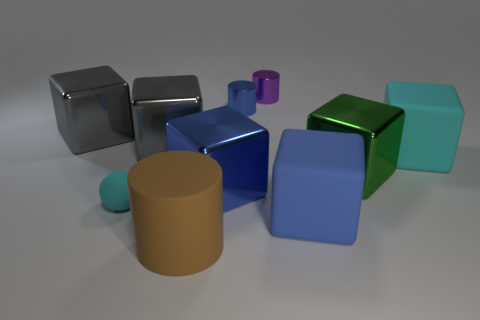How many blue blocks must be subtracted to get 1 blue blocks? 1 Subtract all green blocks. How many blocks are left? 5 Subtract all green blocks. How many blocks are left? 5 Subtract all yellow balls. Subtract all brown cubes. How many balls are left? 1 Subtract all balls. How many objects are left? 9 Add 6 large cyan matte blocks. How many large cyan matte blocks are left? 7 Add 4 large purple things. How many large purple things exist? 4 Subtract 0 cyan cylinders. How many objects are left? 10 Subtract all tiny yellow things. Subtract all big brown things. How many objects are left? 9 